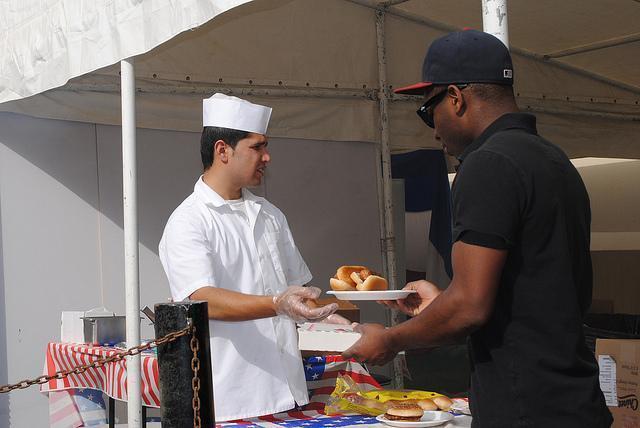How many rolls is the man holding?
Give a very brief answer. 2. How many people can you see?
Give a very brief answer. 2. How many dining tables are there?
Give a very brief answer. 2. 